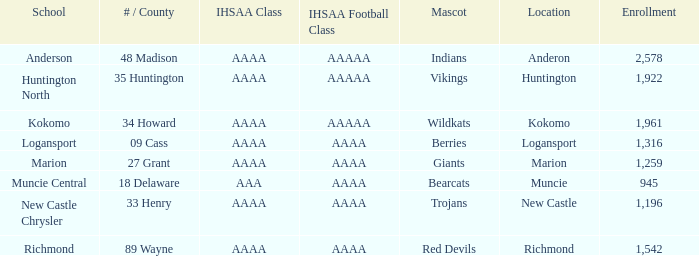What's the least enrolled when the mascot was the Trojans? 1196.0. 